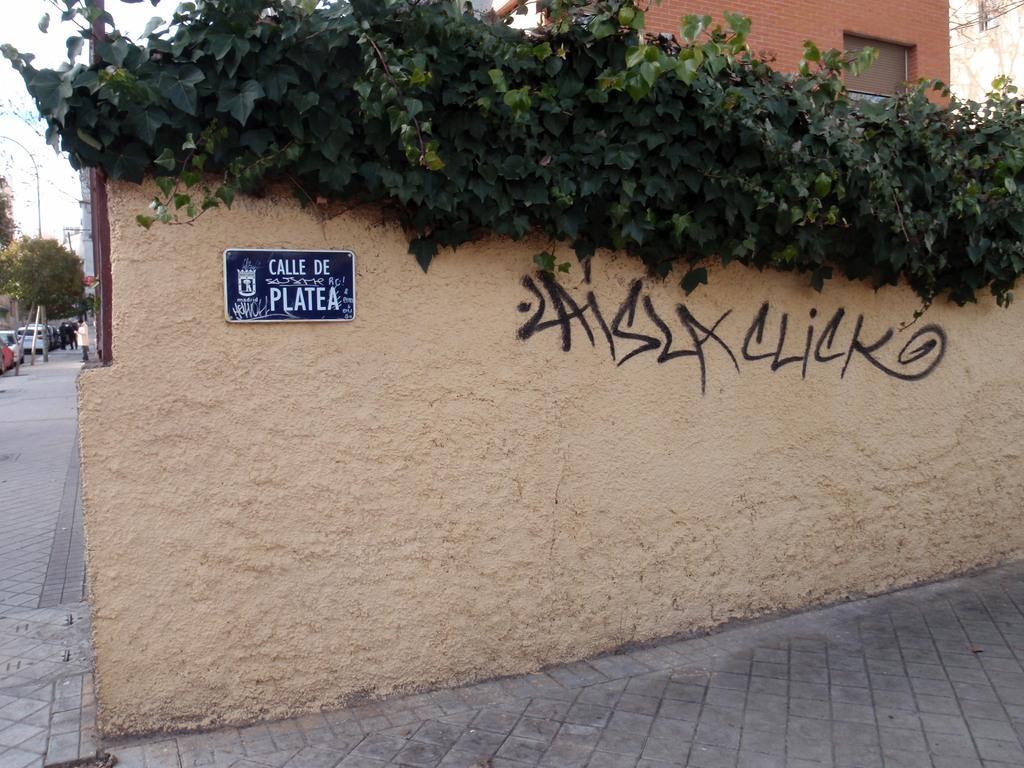How would you summarize this image in a sentence or two? In this image we can see road, board and text written on the wall and plants. In the background on the left side we can see vehicles on the road, few persons, trees, poles and the sky. On the right side we can see a building and window. 